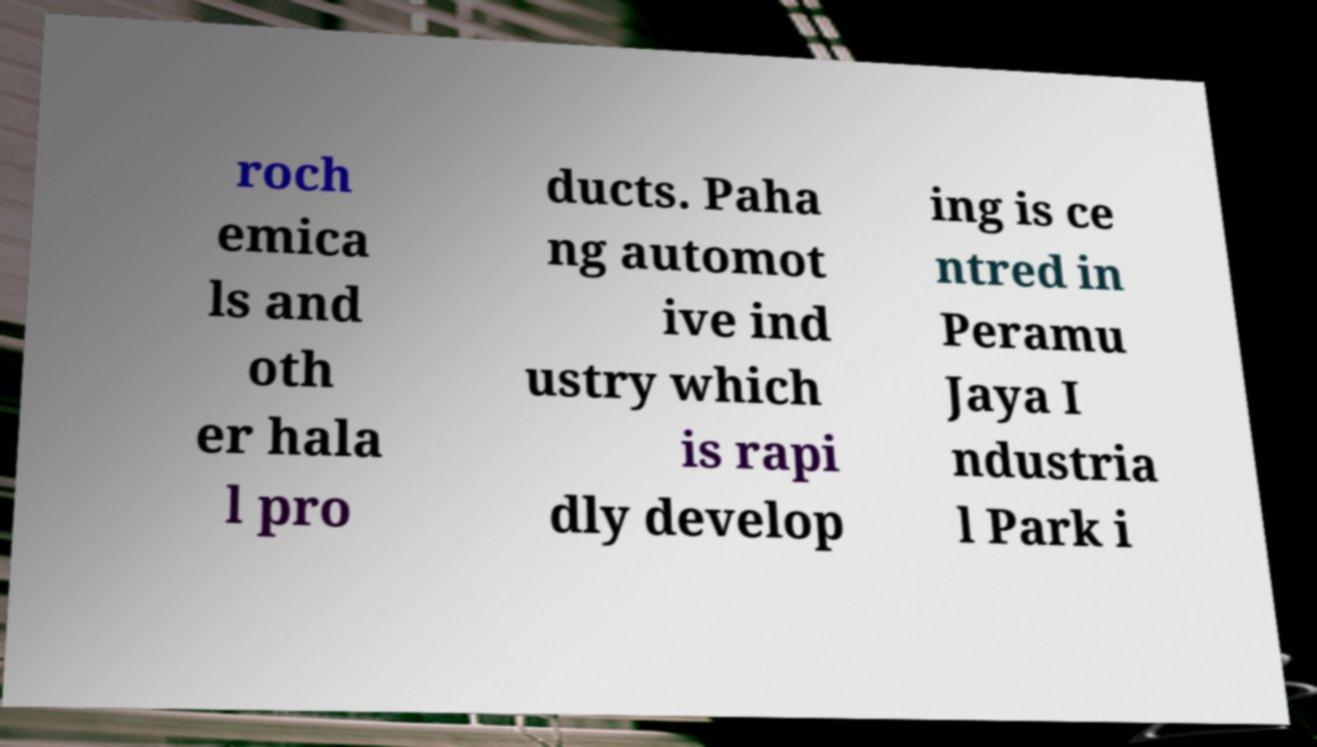For documentation purposes, I need the text within this image transcribed. Could you provide that? roch emica ls and oth er hala l pro ducts. Paha ng automot ive ind ustry which is rapi dly develop ing is ce ntred in Peramu Jaya I ndustria l Park i 